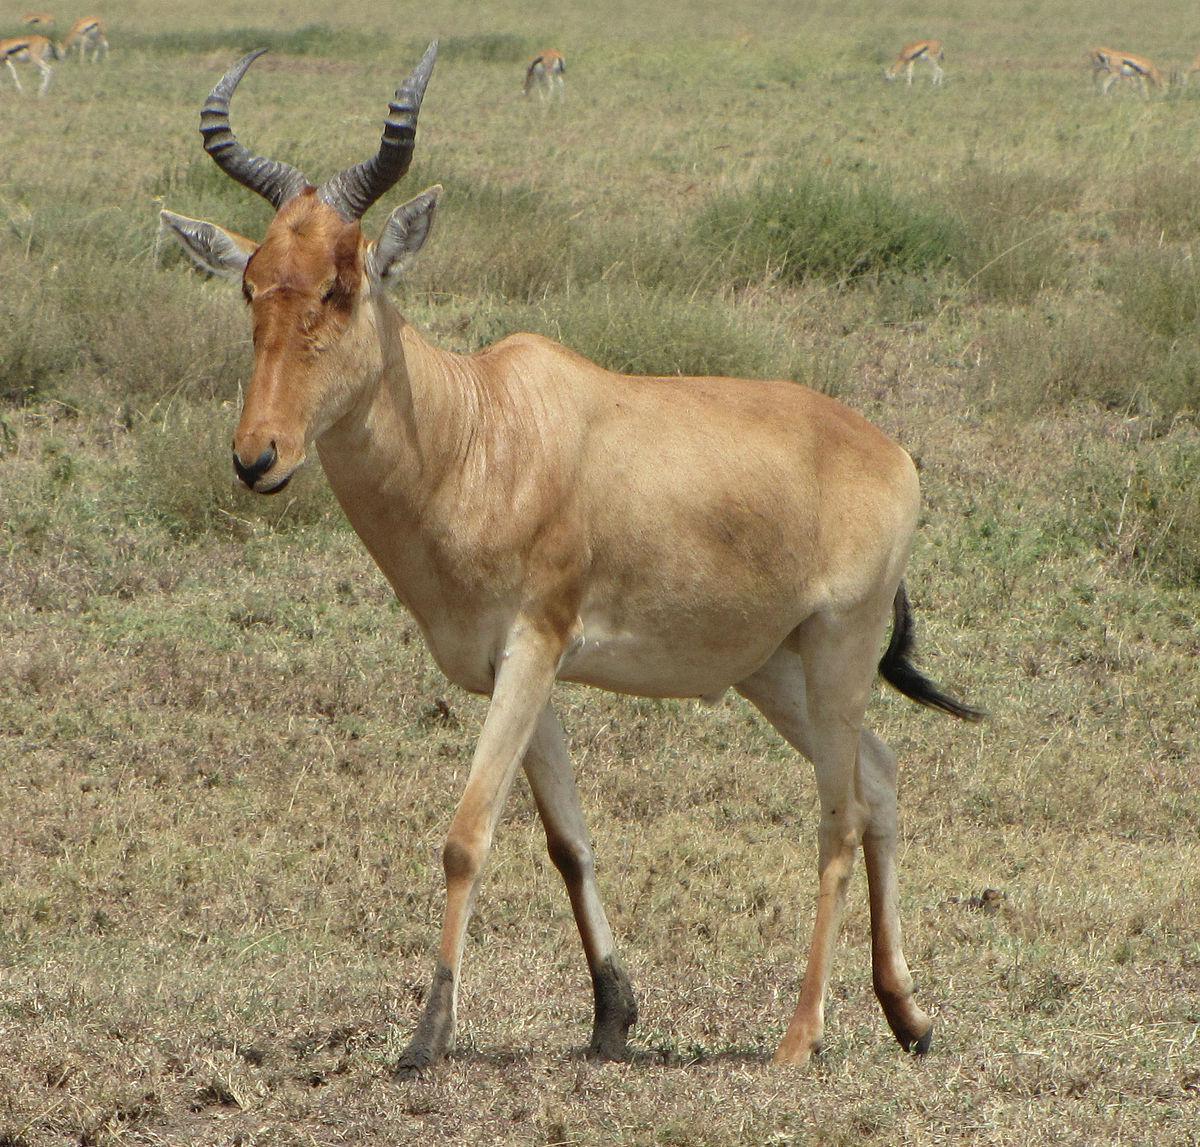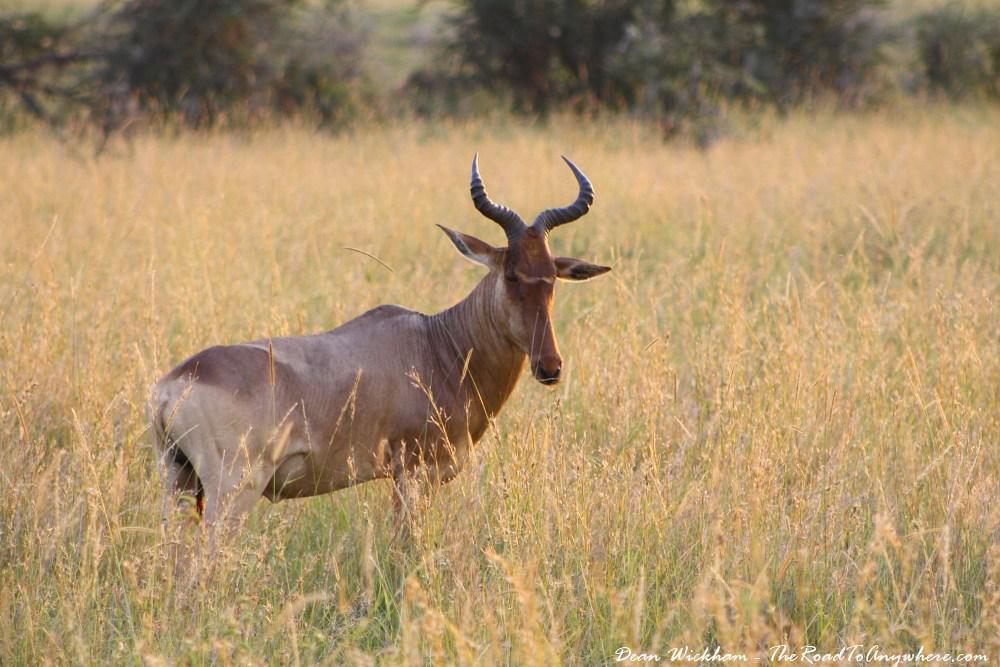The first image is the image on the left, the second image is the image on the right. Considering the images on both sides, is "Both images feature animals facing the same direction." valid? Answer yes or no. No. 